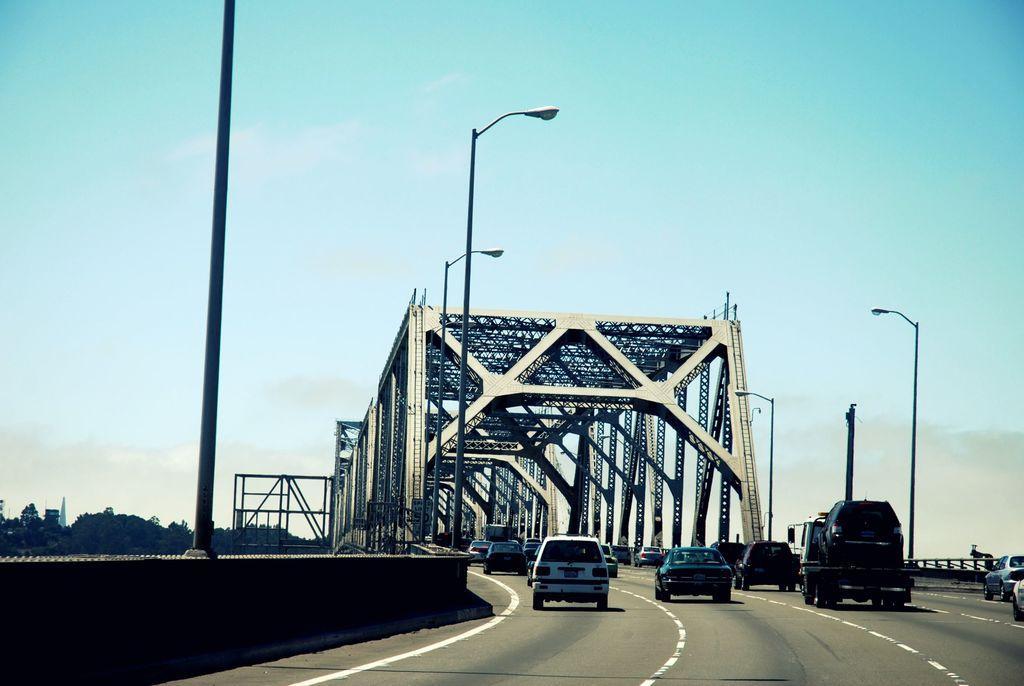Can you describe this image briefly? In this image, there are a few vehicles, poles, metallic arches. We can see the ground. We can also see the wall and the sky with clouds. We can also see some objects on the left. 